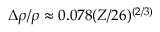Convert formula to latex. <formula><loc_0><loc_0><loc_500><loc_500>\Delta \rho / \rho \approx 0 . 0 7 8 ( Z / 2 6 ) ^ { ( 2 / 3 ) }</formula> 